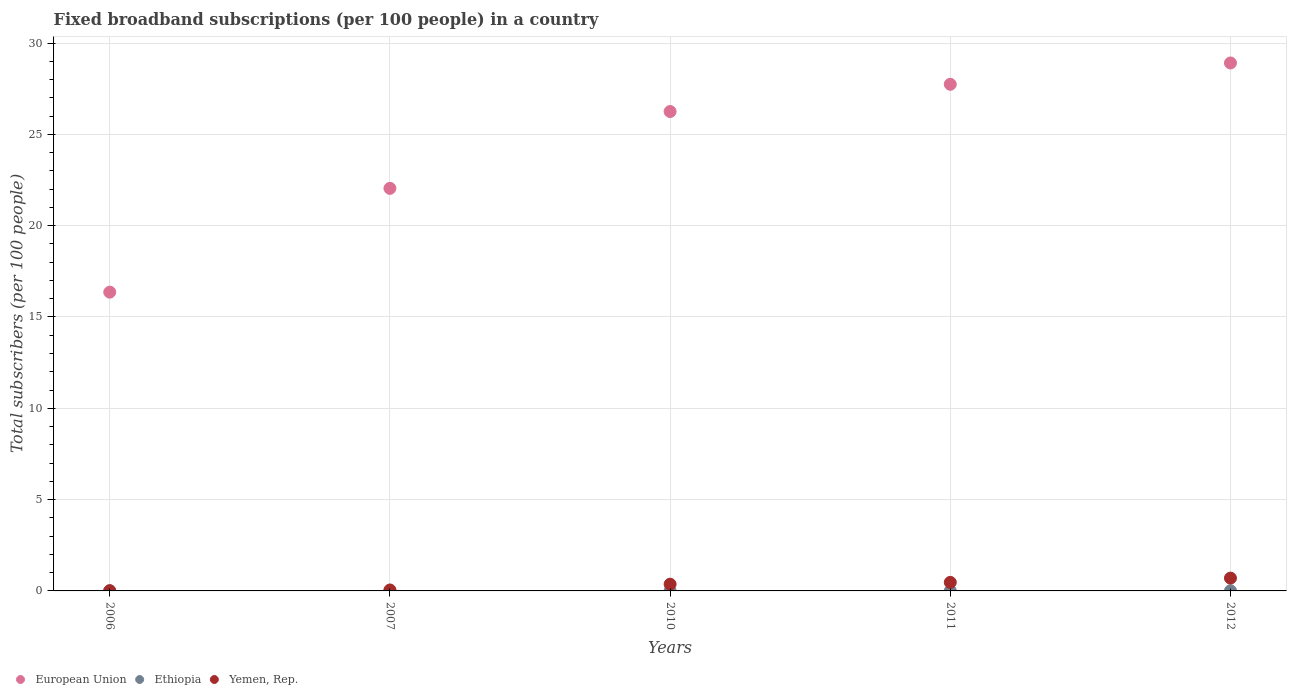Is the number of dotlines equal to the number of legend labels?
Your answer should be very brief. Yes. What is the number of broadband subscriptions in Yemen, Rep. in 2011?
Your answer should be very brief. 0.47. Across all years, what is the maximum number of broadband subscriptions in Ethiopia?
Make the answer very short. 0.01. Across all years, what is the minimum number of broadband subscriptions in European Union?
Keep it short and to the point. 16.36. In which year was the number of broadband subscriptions in European Union maximum?
Your answer should be very brief. 2012. What is the total number of broadband subscriptions in European Union in the graph?
Offer a very short reply. 121.3. What is the difference between the number of broadband subscriptions in Yemen, Rep. in 2007 and that in 2012?
Your response must be concise. -0.65. What is the difference between the number of broadband subscriptions in European Union in 2011 and the number of broadband subscriptions in Yemen, Rep. in 2010?
Your response must be concise. 27.37. What is the average number of broadband subscriptions in European Union per year?
Your answer should be compact. 24.26. In the year 2011, what is the difference between the number of broadband subscriptions in European Union and number of broadband subscriptions in Yemen, Rep.?
Offer a very short reply. 27.27. What is the ratio of the number of broadband subscriptions in Ethiopia in 2010 to that in 2012?
Your answer should be very brief. 0.51. Is the number of broadband subscriptions in European Union in 2006 less than that in 2012?
Your answer should be very brief. Yes. Is the difference between the number of broadband subscriptions in European Union in 2010 and 2012 greater than the difference between the number of broadband subscriptions in Yemen, Rep. in 2010 and 2012?
Give a very brief answer. No. What is the difference between the highest and the second highest number of broadband subscriptions in Ethiopia?
Offer a terse response. 0. What is the difference between the highest and the lowest number of broadband subscriptions in Yemen, Rep.?
Give a very brief answer. 0.69. Is it the case that in every year, the sum of the number of broadband subscriptions in Ethiopia and number of broadband subscriptions in Yemen, Rep.  is greater than the number of broadband subscriptions in European Union?
Ensure brevity in your answer.  No. Does the number of broadband subscriptions in Yemen, Rep. monotonically increase over the years?
Offer a terse response. Yes. Is the number of broadband subscriptions in Ethiopia strictly less than the number of broadband subscriptions in Yemen, Rep. over the years?
Give a very brief answer. Yes. Where does the legend appear in the graph?
Your response must be concise. Bottom left. How many legend labels are there?
Give a very brief answer. 3. What is the title of the graph?
Your response must be concise. Fixed broadband subscriptions (per 100 people) in a country. Does "Chile" appear as one of the legend labels in the graph?
Provide a succinct answer. No. What is the label or title of the Y-axis?
Make the answer very short. Total subscribers (per 100 people). What is the Total subscribers (per 100 people) of European Union in 2006?
Your answer should be very brief. 16.36. What is the Total subscribers (per 100 people) in Ethiopia in 2006?
Ensure brevity in your answer.  0. What is the Total subscribers (per 100 people) of Yemen, Rep. in 2006?
Your response must be concise. 0.01. What is the Total subscribers (per 100 people) in European Union in 2007?
Your response must be concise. 22.04. What is the Total subscribers (per 100 people) in Ethiopia in 2007?
Keep it short and to the point. 0. What is the Total subscribers (per 100 people) of Yemen, Rep. in 2007?
Offer a terse response. 0.05. What is the Total subscribers (per 100 people) of European Union in 2010?
Your response must be concise. 26.25. What is the Total subscribers (per 100 people) in Ethiopia in 2010?
Give a very brief answer. 0. What is the Total subscribers (per 100 people) in Yemen, Rep. in 2010?
Provide a succinct answer. 0.37. What is the Total subscribers (per 100 people) of European Union in 2011?
Make the answer very short. 27.74. What is the Total subscribers (per 100 people) of Ethiopia in 2011?
Your answer should be very brief. 0.01. What is the Total subscribers (per 100 people) in Yemen, Rep. in 2011?
Give a very brief answer. 0.47. What is the Total subscribers (per 100 people) in European Union in 2012?
Give a very brief answer. 28.91. What is the Total subscribers (per 100 people) in Ethiopia in 2012?
Your answer should be very brief. 0.01. What is the Total subscribers (per 100 people) in Yemen, Rep. in 2012?
Ensure brevity in your answer.  0.7. Across all years, what is the maximum Total subscribers (per 100 people) of European Union?
Your answer should be compact. 28.91. Across all years, what is the maximum Total subscribers (per 100 people) in Ethiopia?
Keep it short and to the point. 0.01. Across all years, what is the maximum Total subscribers (per 100 people) in Yemen, Rep.?
Your answer should be compact. 0.7. Across all years, what is the minimum Total subscribers (per 100 people) of European Union?
Keep it short and to the point. 16.36. Across all years, what is the minimum Total subscribers (per 100 people) of Ethiopia?
Make the answer very short. 0. Across all years, what is the minimum Total subscribers (per 100 people) of Yemen, Rep.?
Ensure brevity in your answer.  0.01. What is the total Total subscribers (per 100 people) in European Union in the graph?
Provide a short and direct response. 121.3. What is the total Total subscribers (per 100 people) of Ethiopia in the graph?
Your answer should be compact. 0.02. What is the total Total subscribers (per 100 people) in Yemen, Rep. in the graph?
Offer a very short reply. 1.6. What is the difference between the Total subscribers (per 100 people) in European Union in 2006 and that in 2007?
Ensure brevity in your answer.  -5.68. What is the difference between the Total subscribers (per 100 people) in Ethiopia in 2006 and that in 2007?
Offer a terse response. -0. What is the difference between the Total subscribers (per 100 people) of Yemen, Rep. in 2006 and that in 2007?
Your answer should be compact. -0.04. What is the difference between the Total subscribers (per 100 people) in European Union in 2006 and that in 2010?
Your answer should be very brief. -9.89. What is the difference between the Total subscribers (per 100 people) in Ethiopia in 2006 and that in 2010?
Your response must be concise. -0. What is the difference between the Total subscribers (per 100 people) in Yemen, Rep. in 2006 and that in 2010?
Provide a short and direct response. -0.36. What is the difference between the Total subscribers (per 100 people) of European Union in 2006 and that in 2011?
Offer a very short reply. -11.38. What is the difference between the Total subscribers (per 100 people) of Ethiopia in 2006 and that in 2011?
Keep it short and to the point. -0.01. What is the difference between the Total subscribers (per 100 people) in Yemen, Rep. in 2006 and that in 2011?
Offer a terse response. -0.45. What is the difference between the Total subscribers (per 100 people) of European Union in 2006 and that in 2012?
Your answer should be compact. -12.55. What is the difference between the Total subscribers (per 100 people) in Ethiopia in 2006 and that in 2012?
Ensure brevity in your answer.  -0.01. What is the difference between the Total subscribers (per 100 people) in Yemen, Rep. in 2006 and that in 2012?
Provide a succinct answer. -0.69. What is the difference between the Total subscribers (per 100 people) of European Union in 2007 and that in 2010?
Keep it short and to the point. -4.21. What is the difference between the Total subscribers (per 100 people) of Ethiopia in 2007 and that in 2010?
Give a very brief answer. -0. What is the difference between the Total subscribers (per 100 people) in Yemen, Rep. in 2007 and that in 2010?
Make the answer very short. -0.32. What is the difference between the Total subscribers (per 100 people) in European Union in 2007 and that in 2011?
Provide a succinct answer. -5.7. What is the difference between the Total subscribers (per 100 people) of Ethiopia in 2007 and that in 2011?
Ensure brevity in your answer.  -0.01. What is the difference between the Total subscribers (per 100 people) of Yemen, Rep. in 2007 and that in 2011?
Provide a succinct answer. -0.42. What is the difference between the Total subscribers (per 100 people) in European Union in 2007 and that in 2012?
Give a very brief answer. -6.87. What is the difference between the Total subscribers (per 100 people) in Ethiopia in 2007 and that in 2012?
Your answer should be very brief. -0.01. What is the difference between the Total subscribers (per 100 people) in Yemen, Rep. in 2007 and that in 2012?
Make the answer very short. -0.65. What is the difference between the Total subscribers (per 100 people) of European Union in 2010 and that in 2011?
Your answer should be compact. -1.49. What is the difference between the Total subscribers (per 100 people) of Ethiopia in 2010 and that in 2011?
Your answer should be compact. -0. What is the difference between the Total subscribers (per 100 people) of Yemen, Rep. in 2010 and that in 2011?
Your answer should be compact. -0.1. What is the difference between the Total subscribers (per 100 people) of European Union in 2010 and that in 2012?
Give a very brief answer. -2.66. What is the difference between the Total subscribers (per 100 people) of Ethiopia in 2010 and that in 2012?
Provide a succinct answer. -0. What is the difference between the Total subscribers (per 100 people) in Yemen, Rep. in 2010 and that in 2012?
Give a very brief answer. -0.33. What is the difference between the Total subscribers (per 100 people) of European Union in 2011 and that in 2012?
Offer a terse response. -1.17. What is the difference between the Total subscribers (per 100 people) of Ethiopia in 2011 and that in 2012?
Your answer should be compact. -0. What is the difference between the Total subscribers (per 100 people) in Yemen, Rep. in 2011 and that in 2012?
Keep it short and to the point. -0.23. What is the difference between the Total subscribers (per 100 people) in European Union in 2006 and the Total subscribers (per 100 people) in Ethiopia in 2007?
Your answer should be very brief. 16.36. What is the difference between the Total subscribers (per 100 people) in European Union in 2006 and the Total subscribers (per 100 people) in Yemen, Rep. in 2007?
Give a very brief answer. 16.31. What is the difference between the Total subscribers (per 100 people) in Ethiopia in 2006 and the Total subscribers (per 100 people) in Yemen, Rep. in 2007?
Your answer should be compact. -0.05. What is the difference between the Total subscribers (per 100 people) in European Union in 2006 and the Total subscribers (per 100 people) in Ethiopia in 2010?
Your answer should be very brief. 16.35. What is the difference between the Total subscribers (per 100 people) of European Union in 2006 and the Total subscribers (per 100 people) of Yemen, Rep. in 2010?
Your response must be concise. 15.99. What is the difference between the Total subscribers (per 100 people) in Ethiopia in 2006 and the Total subscribers (per 100 people) in Yemen, Rep. in 2010?
Provide a succinct answer. -0.37. What is the difference between the Total subscribers (per 100 people) in European Union in 2006 and the Total subscribers (per 100 people) in Ethiopia in 2011?
Provide a succinct answer. 16.35. What is the difference between the Total subscribers (per 100 people) of European Union in 2006 and the Total subscribers (per 100 people) of Yemen, Rep. in 2011?
Make the answer very short. 15.89. What is the difference between the Total subscribers (per 100 people) of Ethiopia in 2006 and the Total subscribers (per 100 people) of Yemen, Rep. in 2011?
Provide a succinct answer. -0.47. What is the difference between the Total subscribers (per 100 people) in European Union in 2006 and the Total subscribers (per 100 people) in Ethiopia in 2012?
Your response must be concise. 16.35. What is the difference between the Total subscribers (per 100 people) of European Union in 2006 and the Total subscribers (per 100 people) of Yemen, Rep. in 2012?
Offer a terse response. 15.66. What is the difference between the Total subscribers (per 100 people) of Ethiopia in 2006 and the Total subscribers (per 100 people) of Yemen, Rep. in 2012?
Provide a short and direct response. -0.7. What is the difference between the Total subscribers (per 100 people) of European Union in 2007 and the Total subscribers (per 100 people) of Ethiopia in 2010?
Provide a short and direct response. 22.04. What is the difference between the Total subscribers (per 100 people) in European Union in 2007 and the Total subscribers (per 100 people) in Yemen, Rep. in 2010?
Make the answer very short. 21.67. What is the difference between the Total subscribers (per 100 people) of Ethiopia in 2007 and the Total subscribers (per 100 people) of Yemen, Rep. in 2010?
Give a very brief answer. -0.37. What is the difference between the Total subscribers (per 100 people) of European Union in 2007 and the Total subscribers (per 100 people) of Ethiopia in 2011?
Your answer should be compact. 22.04. What is the difference between the Total subscribers (per 100 people) of European Union in 2007 and the Total subscribers (per 100 people) of Yemen, Rep. in 2011?
Give a very brief answer. 21.58. What is the difference between the Total subscribers (per 100 people) in Ethiopia in 2007 and the Total subscribers (per 100 people) in Yemen, Rep. in 2011?
Provide a succinct answer. -0.47. What is the difference between the Total subscribers (per 100 people) of European Union in 2007 and the Total subscribers (per 100 people) of Ethiopia in 2012?
Give a very brief answer. 22.03. What is the difference between the Total subscribers (per 100 people) of European Union in 2007 and the Total subscribers (per 100 people) of Yemen, Rep. in 2012?
Offer a very short reply. 21.34. What is the difference between the Total subscribers (per 100 people) in Ethiopia in 2007 and the Total subscribers (per 100 people) in Yemen, Rep. in 2012?
Keep it short and to the point. -0.7. What is the difference between the Total subscribers (per 100 people) in European Union in 2010 and the Total subscribers (per 100 people) in Ethiopia in 2011?
Your response must be concise. 26.24. What is the difference between the Total subscribers (per 100 people) of European Union in 2010 and the Total subscribers (per 100 people) of Yemen, Rep. in 2011?
Provide a succinct answer. 25.78. What is the difference between the Total subscribers (per 100 people) in Ethiopia in 2010 and the Total subscribers (per 100 people) in Yemen, Rep. in 2011?
Your answer should be very brief. -0.46. What is the difference between the Total subscribers (per 100 people) of European Union in 2010 and the Total subscribers (per 100 people) of Ethiopia in 2012?
Provide a short and direct response. 26.24. What is the difference between the Total subscribers (per 100 people) of European Union in 2010 and the Total subscribers (per 100 people) of Yemen, Rep. in 2012?
Your answer should be very brief. 25.55. What is the difference between the Total subscribers (per 100 people) in Ethiopia in 2010 and the Total subscribers (per 100 people) in Yemen, Rep. in 2012?
Your answer should be compact. -0.7. What is the difference between the Total subscribers (per 100 people) in European Union in 2011 and the Total subscribers (per 100 people) in Ethiopia in 2012?
Offer a terse response. 27.73. What is the difference between the Total subscribers (per 100 people) in European Union in 2011 and the Total subscribers (per 100 people) in Yemen, Rep. in 2012?
Your answer should be compact. 27.04. What is the difference between the Total subscribers (per 100 people) of Ethiopia in 2011 and the Total subscribers (per 100 people) of Yemen, Rep. in 2012?
Your response must be concise. -0.69. What is the average Total subscribers (per 100 people) of European Union per year?
Provide a short and direct response. 24.26. What is the average Total subscribers (per 100 people) in Ethiopia per year?
Ensure brevity in your answer.  0. What is the average Total subscribers (per 100 people) in Yemen, Rep. per year?
Provide a succinct answer. 0.32. In the year 2006, what is the difference between the Total subscribers (per 100 people) in European Union and Total subscribers (per 100 people) in Ethiopia?
Your response must be concise. 16.36. In the year 2006, what is the difference between the Total subscribers (per 100 people) of European Union and Total subscribers (per 100 people) of Yemen, Rep.?
Ensure brevity in your answer.  16.35. In the year 2006, what is the difference between the Total subscribers (per 100 people) in Ethiopia and Total subscribers (per 100 people) in Yemen, Rep.?
Offer a terse response. -0.01. In the year 2007, what is the difference between the Total subscribers (per 100 people) of European Union and Total subscribers (per 100 people) of Ethiopia?
Your answer should be very brief. 22.04. In the year 2007, what is the difference between the Total subscribers (per 100 people) of European Union and Total subscribers (per 100 people) of Yemen, Rep.?
Offer a terse response. 21.99. In the year 2007, what is the difference between the Total subscribers (per 100 people) of Ethiopia and Total subscribers (per 100 people) of Yemen, Rep.?
Offer a terse response. -0.05. In the year 2010, what is the difference between the Total subscribers (per 100 people) of European Union and Total subscribers (per 100 people) of Ethiopia?
Offer a very short reply. 26.25. In the year 2010, what is the difference between the Total subscribers (per 100 people) of European Union and Total subscribers (per 100 people) of Yemen, Rep.?
Provide a short and direct response. 25.88. In the year 2010, what is the difference between the Total subscribers (per 100 people) of Ethiopia and Total subscribers (per 100 people) of Yemen, Rep.?
Your answer should be very brief. -0.36. In the year 2011, what is the difference between the Total subscribers (per 100 people) in European Union and Total subscribers (per 100 people) in Ethiopia?
Give a very brief answer. 27.73. In the year 2011, what is the difference between the Total subscribers (per 100 people) of European Union and Total subscribers (per 100 people) of Yemen, Rep.?
Provide a succinct answer. 27.27. In the year 2011, what is the difference between the Total subscribers (per 100 people) in Ethiopia and Total subscribers (per 100 people) in Yemen, Rep.?
Give a very brief answer. -0.46. In the year 2012, what is the difference between the Total subscribers (per 100 people) in European Union and Total subscribers (per 100 people) in Ethiopia?
Make the answer very short. 28.9. In the year 2012, what is the difference between the Total subscribers (per 100 people) in European Union and Total subscribers (per 100 people) in Yemen, Rep.?
Give a very brief answer. 28.21. In the year 2012, what is the difference between the Total subscribers (per 100 people) in Ethiopia and Total subscribers (per 100 people) in Yemen, Rep.?
Provide a short and direct response. -0.69. What is the ratio of the Total subscribers (per 100 people) in European Union in 2006 to that in 2007?
Give a very brief answer. 0.74. What is the ratio of the Total subscribers (per 100 people) of Ethiopia in 2006 to that in 2007?
Keep it short and to the point. 0.26. What is the ratio of the Total subscribers (per 100 people) of Yemen, Rep. in 2006 to that in 2007?
Keep it short and to the point. 0.26. What is the ratio of the Total subscribers (per 100 people) of European Union in 2006 to that in 2010?
Provide a short and direct response. 0.62. What is the ratio of the Total subscribers (per 100 people) in Ethiopia in 2006 to that in 2010?
Provide a short and direct response. 0.07. What is the ratio of the Total subscribers (per 100 people) of Yemen, Rep. in 2006 to that in 2010?
Your answer should be very brief. 0.04. What is the ratio of the Total subscribers (per 100 people) of European Union in 2006 to that in 2011?
Make the answer very short. 0.59. What is the ratio of the Total subscribers (per 100 people) in Ethiopia in 2006 to that in 2011?
Ensure brevity in your answer.  0.05. What is the ratio of the Total subscribers (per 100 people) of Yemen, Rep. in 2006 to that in 2011?
Keep it short and to the point. 0.03. What is the ratio of the Total subscribers (per 100 people) in European Union in 2006 to that in 2012?
Offer a very short reply. 0.57. What is the ratio of the Total subscribers (per 100 people) in Ethiopia in 2006 to that in 2012?
Offer a very short reply. 0.04. What is the ratio of the Total subscribers (per 100 people) of Yemen, Rep. in 2006 to that in 2012?
Keep it short and to the point. 0.02. What is the ratio of the Total subscribers (per 100 people) in European Union in 2007 to that in 2010?
Provide a succinct answer. 0.84. What is the ratio of the Total subscribers (per 100 people) of Ethiopia in 2007 to that in 2010?
Your answer should be compact. 0.27. What is the ratio of the Total subscribers (per 100 people) in Yemen, Rep. in 2007 to that in 2010?
Ensure brevity in your answer.  0.14. What is the ratio of the Total subscribers (per 100 people) of European Union in 2007 to that in 2011?
Provide a succinct answer. 0.79. What is the ratio of the Total subscribers (per 100 people) of Ethiopia in 2007 to that in 2011?
Provide a succinct answer. 0.18. What is the ratio of the Total subscribers (per 100 people) of Yemen, Rep. in 2007 to that in 2011?
Offer a very short reply. 0.11. What is the ratio of the Total subscribers (per 100 people) in European Union in 2007 to that in 2012?
Offer a very short reply. 0.76. What is the ratio of the Total subscribers (per 100 people) in Ethiopia in 2007 to that in 2012?
Provide a short and direct response. 0.14. What is the ratio of the Total subscribers (per 100 people) of Yemen, Rep. in 2007 to that in 2012?
Your answer should be very brief. 0.07. What is the ratio of the Total subscribers (per 100 people) in European Union in 2010 to that in 2011?
Offer a terse response. 0.95. What is the ratio of the Total subscribers (per 100 people) in Ethiopia in 2010 to that in 2011?
Your response must be concise. 0.66. What is the ratio of the Total subscribers (per 100 people) of Yemen, Rep. in 2010 to that in 2011?
Give a very brief answer. 0.79. What is the ratio of the Total subscribers (per 100 people) of European Union in 2010 to that in 2012?
Make the answer very short. 0.91. What is the ratio of the Total subscribers (per 100 people) of Ethiopia in 2010 to that in 2012?
Ensure brevity in your answer.  0.51. What is the ratio of the Total subscribers (per 100 people) of Yemen, Rep. in 2010 to that in 2012?
Keep it short and to the point. 0.53. What is the ratio of the Total subscribers (per 100 people) in European Union in 2011 to that in 2012?
Provide a succinct answer. 0.96. What is the ratio of the Total subscribers (per 100 people) of Ethiopia in 2011 to that in 2012?
Your answer should be very brief. 0.76. What is the ratio of the Total subscribers (per 100 people) of Yemen, Rep. in 2011 to that in 2012?
Provide a succinct answer. 0.67. What is the difference between the highest and the second highest Total subscribers (per 100 people) in European Union?
Provide a short and direct response. 1.17. What is the difference between the highest and the second highest Total subscribers (per 100 people) of Ethiopia?
Provide a short and direct response. 0. What is the difference between the highest and the second highest Total subscribers (per 100 people) in Yemen, Rep.?
Offer a terse response. 0.23. What is the difference between the highest and the lowest Total subscribers (per 100 people) in European Union?
Keep it short and to the point. 12.55. What is the difference between the highest and the lowest Total subscribers (per 100 people) of Ethiopia?
Provide a succinct answer. 0.01. What is the difference between the highest and the lowest Total subscribers (per 100 people) in Yemen, Rep.?
Offer a terse response. 0.69. 